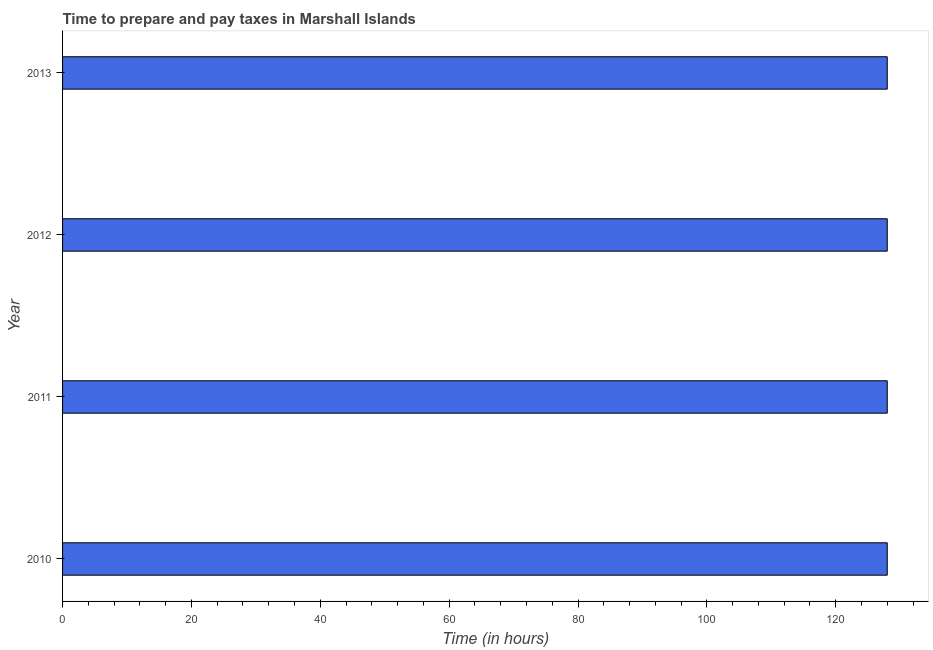Does the graph contain grids?
Give a very brief answer. No. What is the title of the graph?
Keep it short and to the point. Time to prepare and pay taxes in Marshall Islands. What is the label or title of the X-axis?
Ensure brevity in your answer.  Time (in hours). What is the time to prepare and pay taxes in 2011?
Your answer should be compact. 128. Across all years, what is the maximum time to prepare and pay taxes?
Give a very brief answer. 128. Across all years, what is the minimum time to prepare and pay taxes?
Keep it short and to the point. 128. In which year was the time to prepare and pay taxes maximum?
Offer a terse response. 2010. In which year was the time to prepare and pay taxes minimum?
Your response must be concise. 2010. What is the sum of the time to prepare and pay taxes?
Offer a very short reply. 512. What is the difference between the time to prepare and pay taxes in 2010 and 2012?
Your answer should be very brief. 0. What is the average time to prepare and pay taxes per year?
Make the answer very short. 128. What is the median time to prepare and pay taxes?
Ensure brevity in your answer.  128. In how many years, is the time to prepare and pay taxes greater than 8 hours?
Make the answer very short. 4. In how many years, is the time to prepare and pay taxes greater than the average time to prepare and pay taxes taken over all years?
Ensure brevity in your answer.  0. What is the Time (in hours) in 2010?
Make the answer very short. 128. What is the Time (in hours) in 2011?
Provide a short and direct response. 128. What is the Time (in hours) of 2012?
Your answer should be compact. 128. What is the Time (in hours) of 2013?
Your response must be concise. 128. What is the difference between the Time (in hours) in 2010 and 2012?
Offer a terse response. 0. What is the difference between the Time (in hours) in 2011 and 2013?
Your response must be concise. 0. What is the ratio of the Time (in hours) in 2011 to that in 2013?
Provide a short and direct response. 1. What is the ratio of the Time (in hours) in 2012 to that in 2013?
Give a very brief answer. 1. 